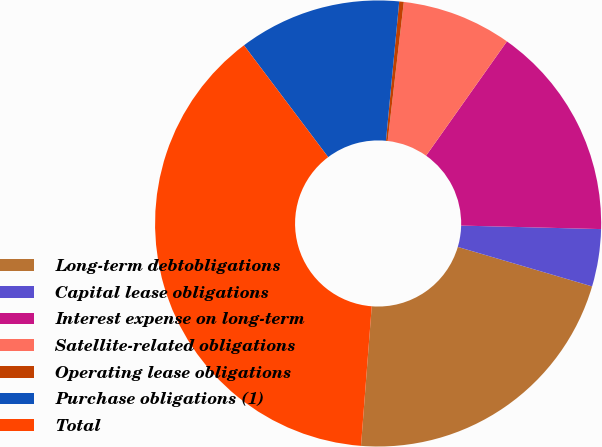Convert chart. <chart><loc_0><loc_0><loc_500><loc_500><pie_chart><fcel>Long-term debtobligations<fcel>Capital lease obligations<fcel>Interest expense on long-term<fcel>Satellite-related obligations<fcel>Operating lease obligations<fcel>Purchase obligations (1)<fcel>Total<nl><fcel>21.67%<fcel>4.15%<fcel>15.6%<fcel>7.96%<fcel>0.33%<fcel>11.78%<fcel>38.5%<nl></chart> 